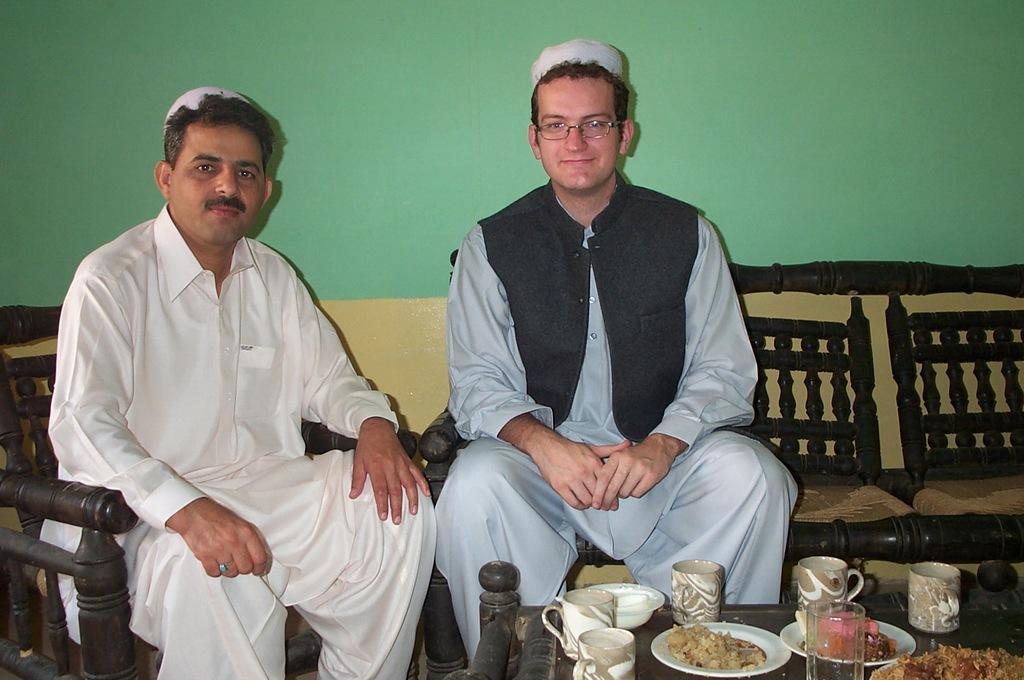Describe this image in one or two sentences. In this picture there are two men sitting and we can see chair and sofa. We can see cups, plates, glass, food and bowl on the table. In the background of the image we can see wall. 